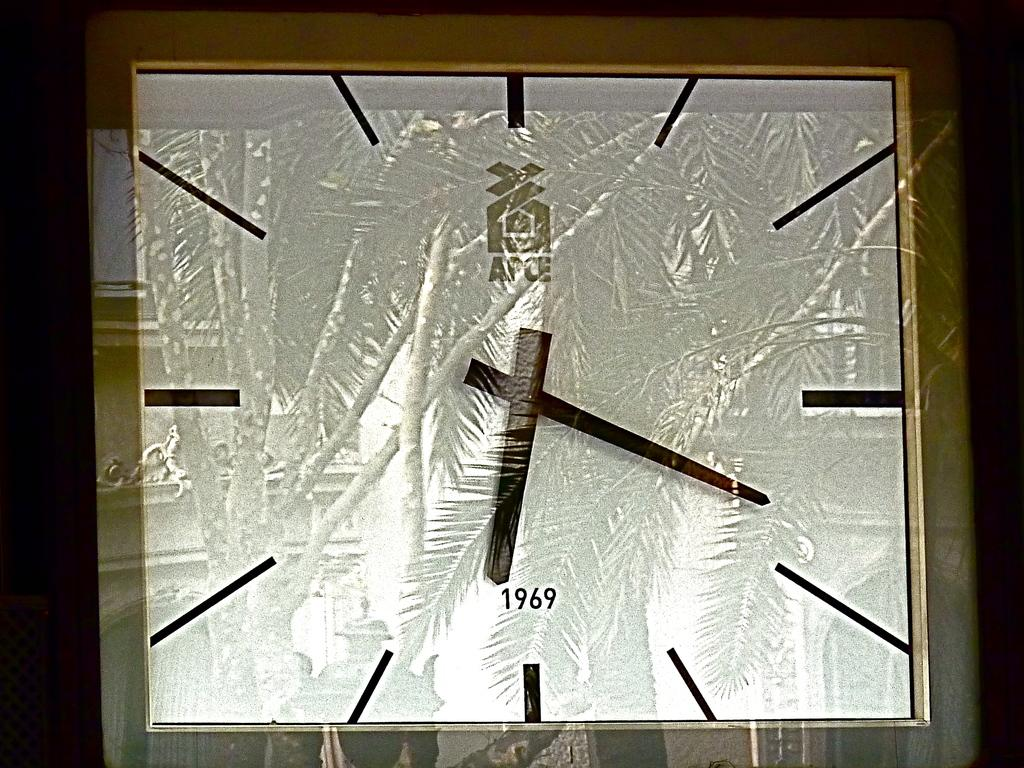<image>
Create a compact narrative representing the image presented. A clock wrapped in plastic has the year 1969 on it. 